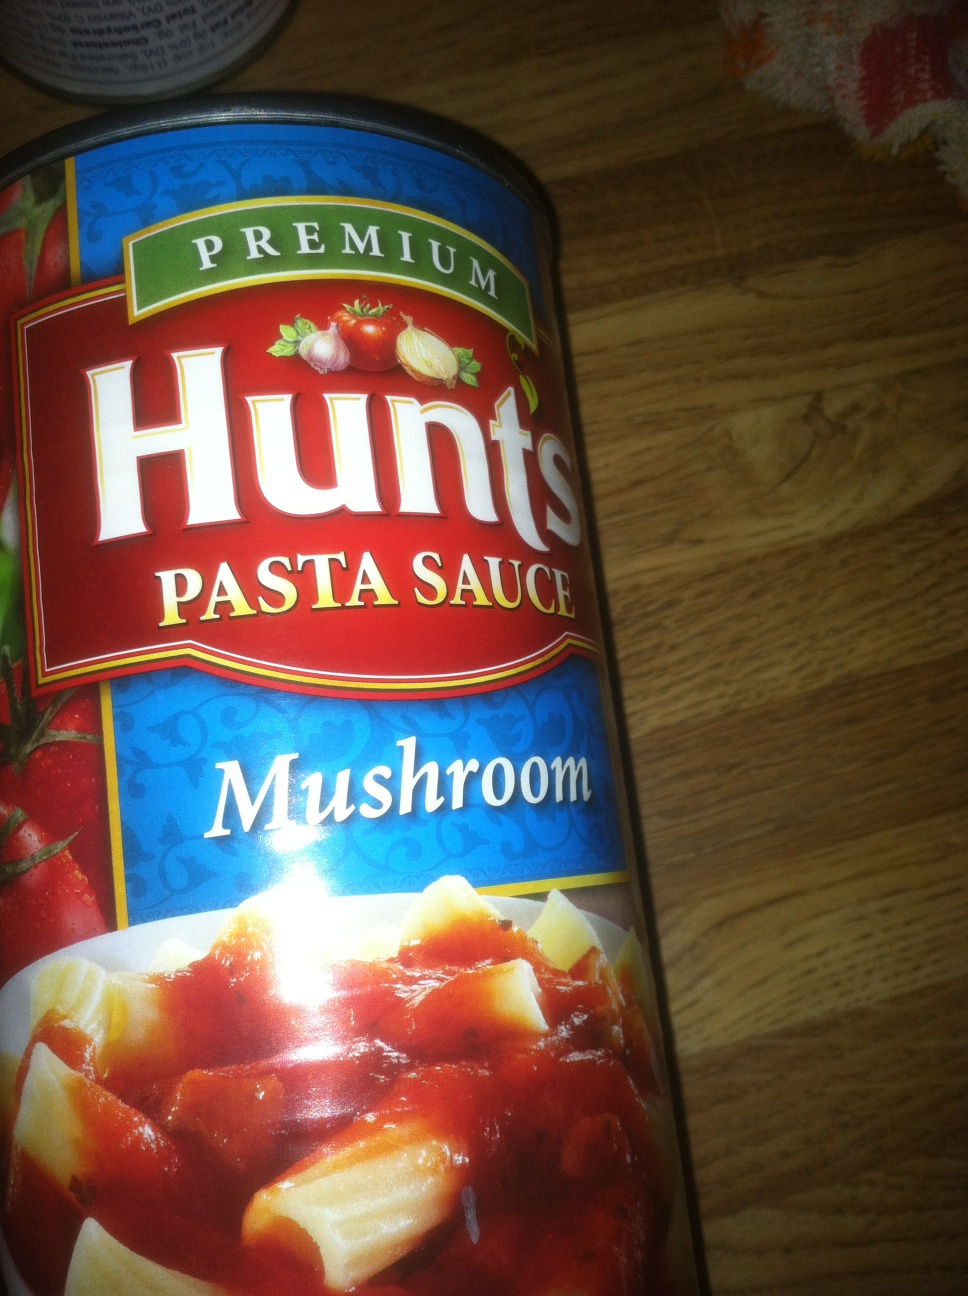What is in this can please? The can contains Hunts Premium Pasta Sauce in a mushroom flavor, as indicated by the label. This sauce is commonly used in various pasta dishes to add a rich, savory mushroom taste. 